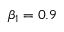<formula> <loc_0><loc_0><loc_500><loc_500>\beta _ { 1 } = 0 . 9</formula> 